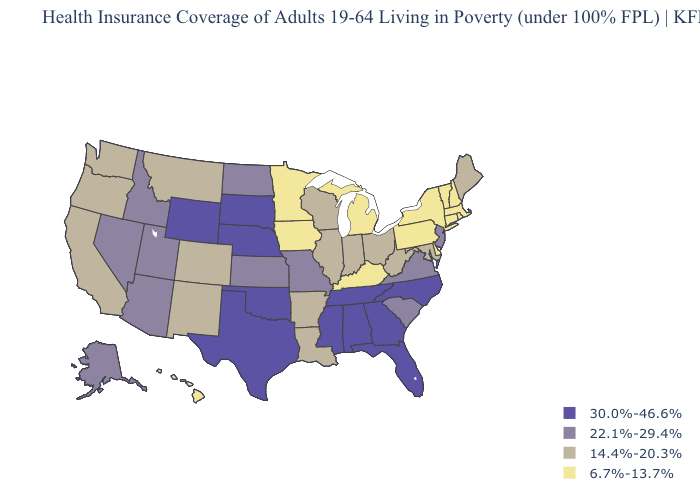What is the value of Alaska?
Concise answer only. 22.1%-29.4%. Which states have the highest value in the USA?
Answer briefly. Alabama, Florida, Georgia, Mississippi, Nebraska, North Carolina, Oklahoma, South Dakota, Tennessee, Texas, Wyoming. Name the states that have a value in the range 30.0%-46.6%?
Quick response, please. Alabama, Florida, Georgia, Mississippi, Nebraska, North Carolina, Oklahoma, South Dakota, Tennessee, Texas, Wyoming. Name the states that have a value in the range 22.1%-29.4%?
Concise answer only. Alaska, Arizona, Idaho, Kansas, Missouri, Nevada, New Jersey, North Dakota, South Carolina, Utah, Virginia. Is the legend a continuous bar?
Answer briefly. No. Is the legend a continuous bar?
Give a very brief answer. No. Name the states that have a value in the range 22.1%-29.4%?
Answer briefly. Alaska, Arizona, Idaho, Kansas, Missouri, Nevada, New Jersey, North Dakota, South Carolina, Utah, Virginia. Does Hawaii have a lower value than Michigan?
Keep it brief. No. What is the value of Alaska?
Answer briefly. 22.1%-29.4%. Among the states that border Kansas , which have the highest value?
Short answer required. Nebraska, Oklahoma. What is the lowest value in the MidWest?
Concise answer only. 6.7%-13.7%. What is the value of Nevada?
Answer briefly. 22.1%-29.4%. What is the value of Georgia?
Answer briefly. 30.0%-46.6%. What is the value of Nebraska?
Short answer required. 30.0%-46.6%. 